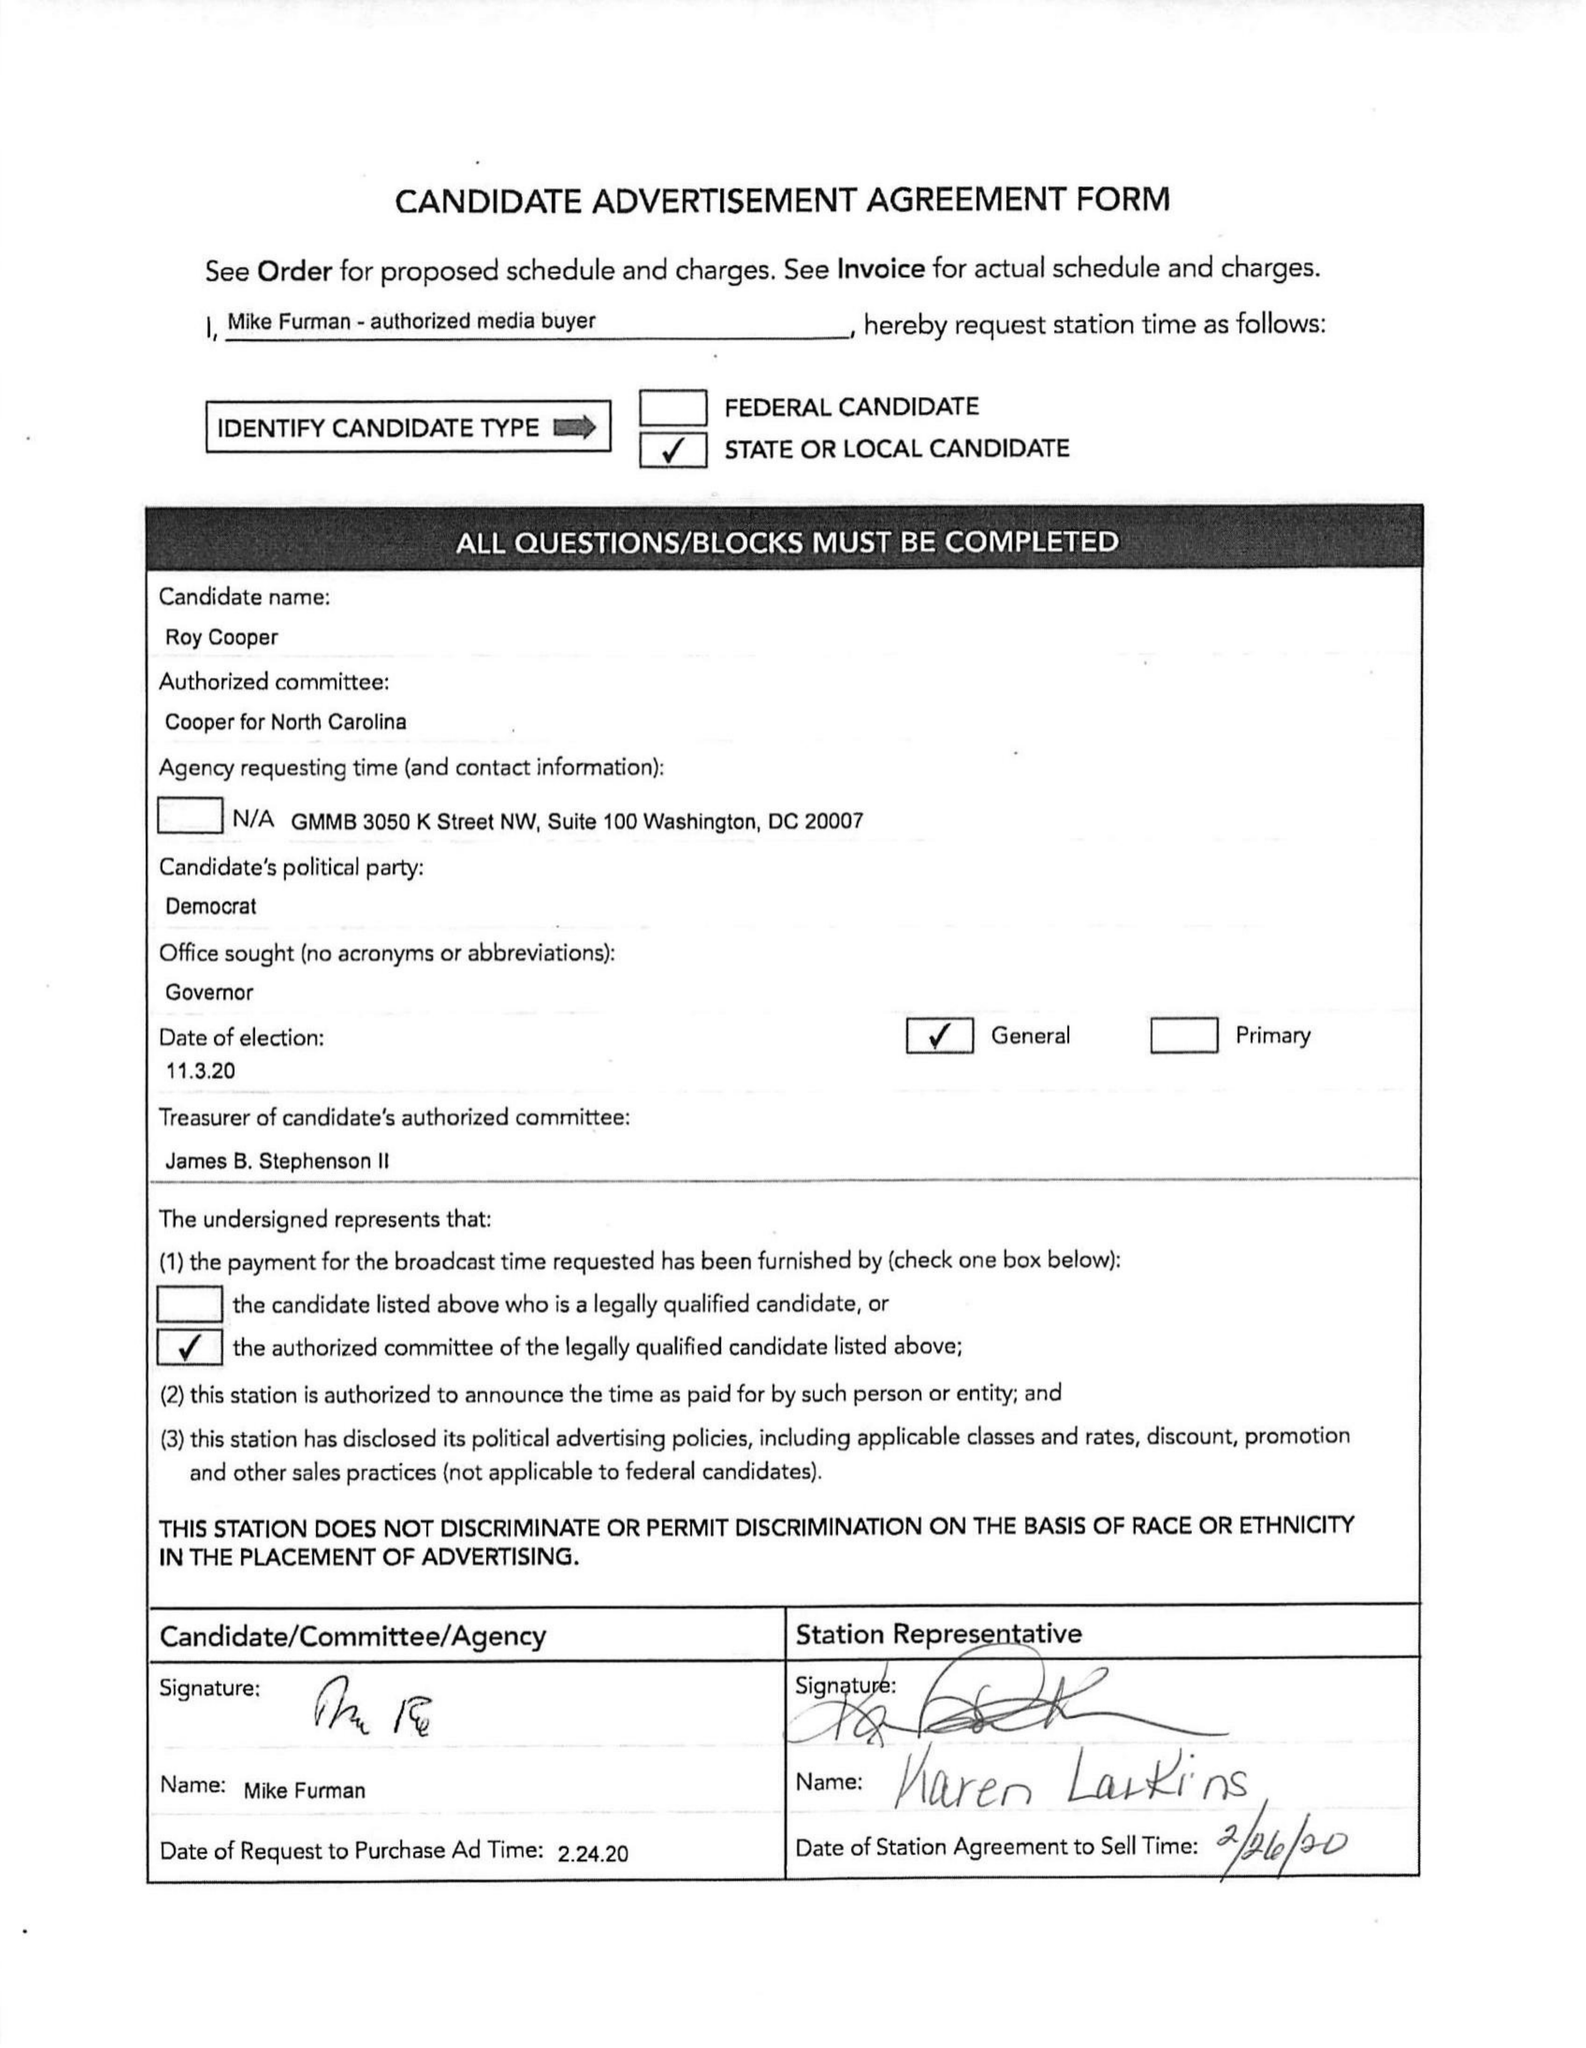What is the value for the flight_from?
Answer the question using a single word or phrase. None 